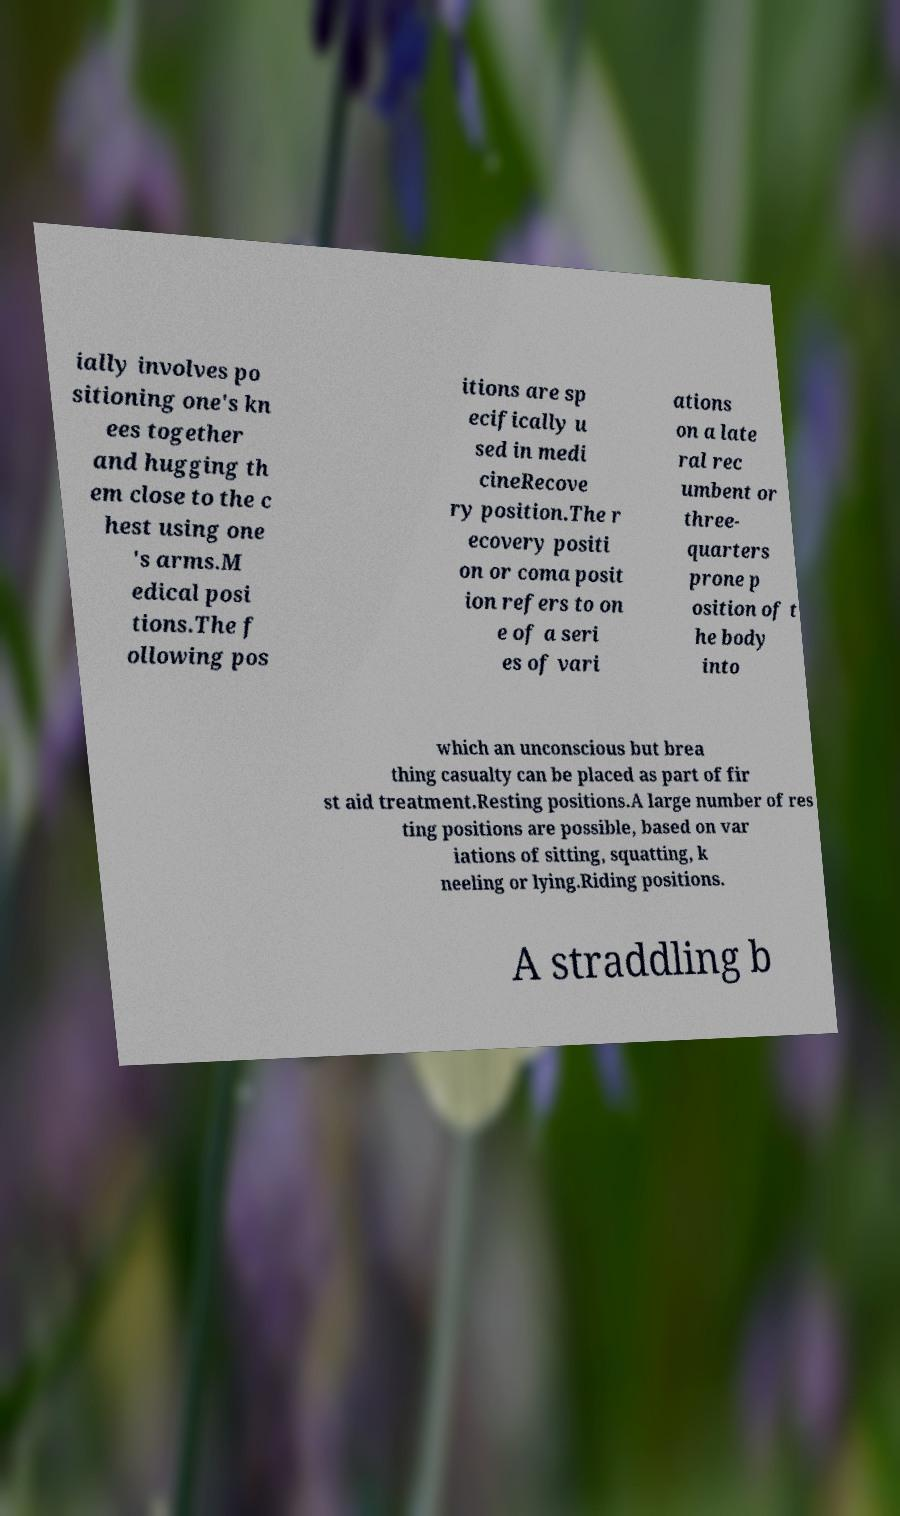Can you read and provide the text displayed in the image?This photo seems to have some interesting text. Can you extract and type it out for me? ially involves po sitioning one's kn ees together and hugging th em close to the c hest using one 's arms.M edical posi tions.The f ollowing pos itions are sp ecifically u sed in medi cineRecove ry position.The r ecovery positi on or coma posit ion refers to on e of a seri es of vari ations on a late ral rec umbent or three- quarters prone p osition of t he body into which an unconscious but brea thing casualty can be placed as part of fir st aid treatment.Resting positions.A large number of res ting positions are possible, based on var iations of sitting, squatting, k neeling or lying.Riding positions. A straddling b 